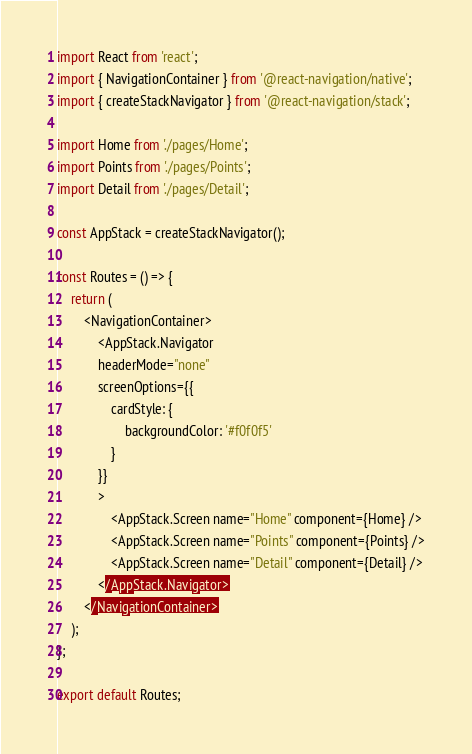<code> <loc_0><loc_0><loc_500><loc_500><_TypeScript_>import React from 'react';
import { NavigationContainer } from '@react-navigation/native';
import { createStackNavigator } from '@react-navigation/stack';

import Home from './pages/Home';
import Points from './pages/Points';
import Detail from './pages/Detail';

const AppStack = createStackNavigator();

const Routes = () => {
    return (
        <NavigationContainer>
            <AppStack.Navigator
            headerMode="none"
            screenOptions={{
                cardStyle: {
                    backgroundColor: '#f0f0f5'
                }
            }}
            >
                <AppStack.Screen name="Home" component={Home} />
                <AppStack.Screen name="Points" component={Points} />
                <AppStack.Screen name="Detail" component={Detail} />
            </AppStack.Navigator>
        </NavigationContainer>
    );
};

export default Routes;</code> 